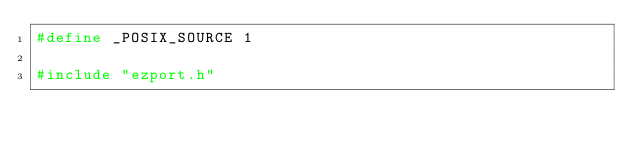<code> <loc_0><loc_0><loc_500><loc_500><_C_>#define _POSIX_SOURCE 1

#include "ezport.h"
</code> 